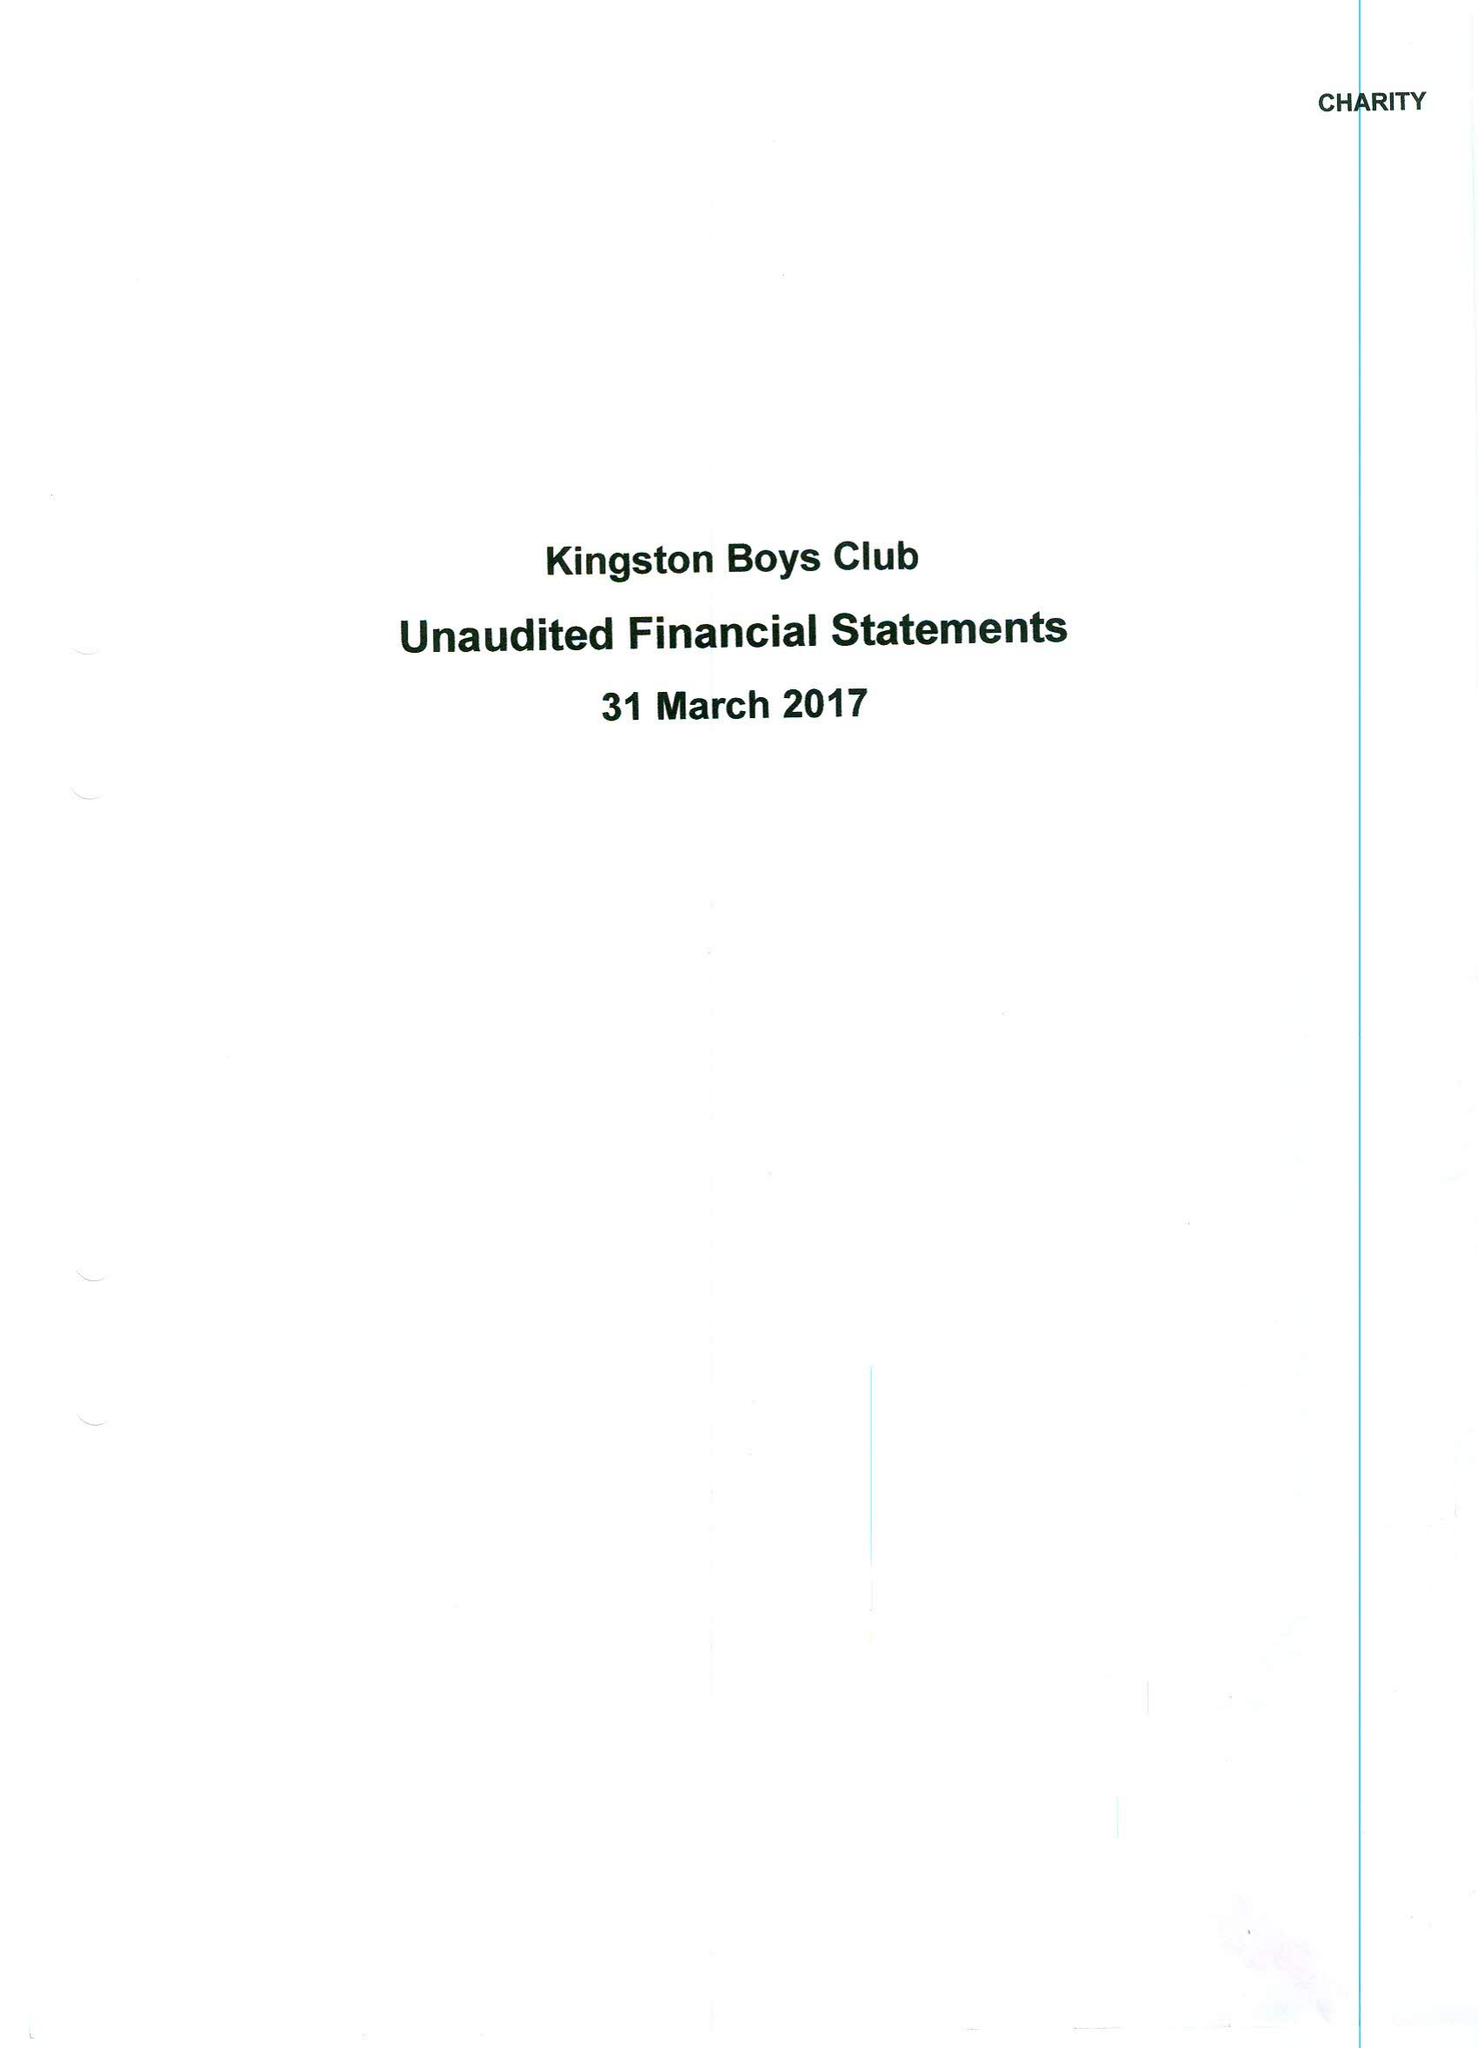What is the value for the spending_annually_in_british_pounds?
Answer the question using a single word or phrase. 25496.00 